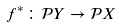Convert formula to latex. <formula><loc_0><loc_0><loc_500><loc_500>f ^ { * } \colon { \mathcal { P } } Y \to { \mathcal { P } } X</formula> 